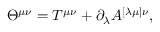Convert formula to latex. <formula><loc_0><loc_0><loc_500><loc_500>\Theta ^ { \mu \nu } = T ^ { \mu \nu } + \partial _ { \lambda } A ^ { [ \lambda \mu ] \nu } ,</formula> 